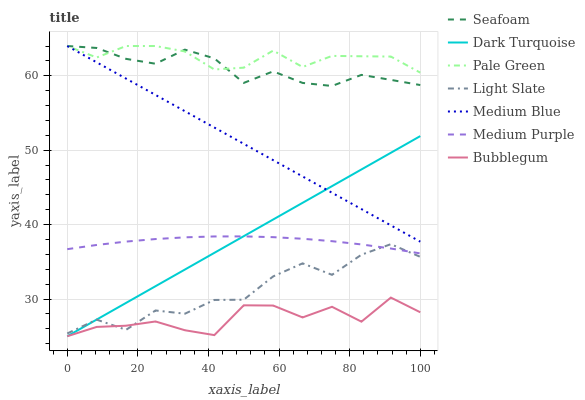Does Dark Turquoise have the minimum area under the curve?
Answer yes or no. No. Does Dark Turquoise have the maximum area under the curve?
Answer yes or no. No. Is Medium Blue the smoothest?
Answer yes or no. No. Is Medium Blue the roughest?
Answer yes or no. No. Does Medium Blue have the lowest value?
Answer yes or no. No. Does Dark Turquoise have the highest value?
Answer yes or no. No. Is Light Slate less than Pale Green?
Answer yes or no. Yes. Is Seafoam greater than Medium Purple?
Answer yes or no. Yes. Does Light Slate intersect Pale Green?
Answer yes or no. No. 